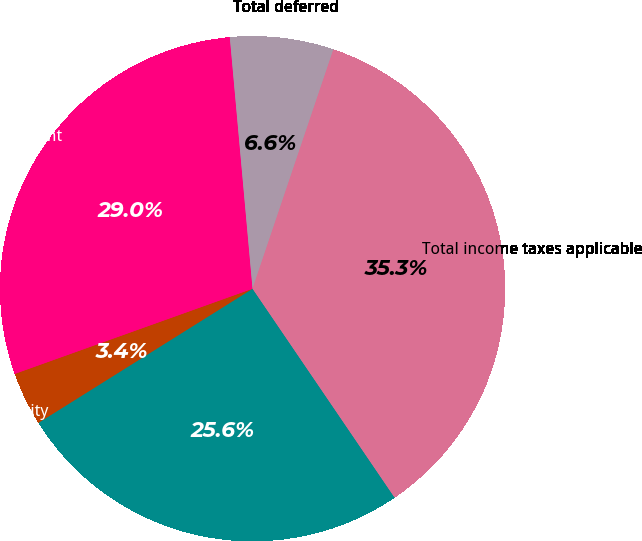Convert chart to OTSL. <chart><loc_0><loc_0><loc_500><loc_500><pie_chart><fcel>Federal<fcel>State and city<fcel>Total current<fcel>Total deferred<fcel>Total income taxes applicable<nl><fcel>25.6%<fcel>3.43%<fcel>29.04%<fcel>6.62%<fcel>35.31%<nl></chart> 